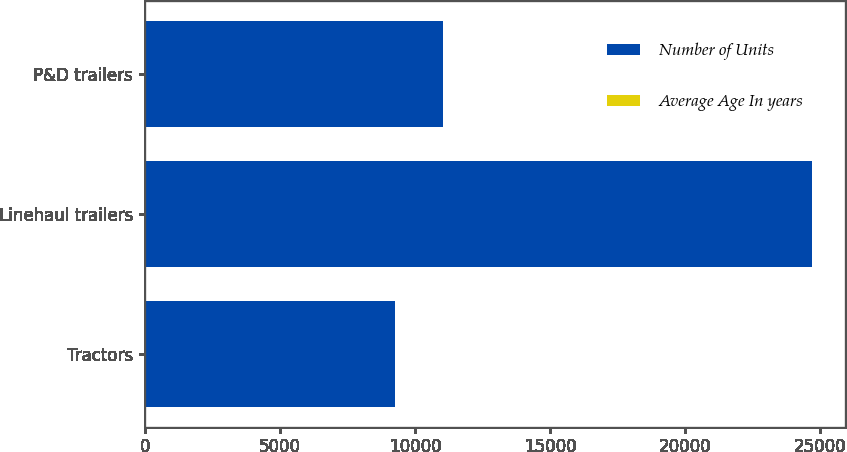Convert chart. <chart><loc_0><loc_0><loc_500><loc_500><stacked_bar_chart><ecel><fcel>Tractors<fcel>Linehaul trailers<fcel>P&D trailers<nl><fcel>Number of Units<fcel>9254<fcel>24685<fcel>11044<nl><fcel>Average Age In years<fcel>3.5<fcel>6.8<fcel>7.4<nl></chart> 